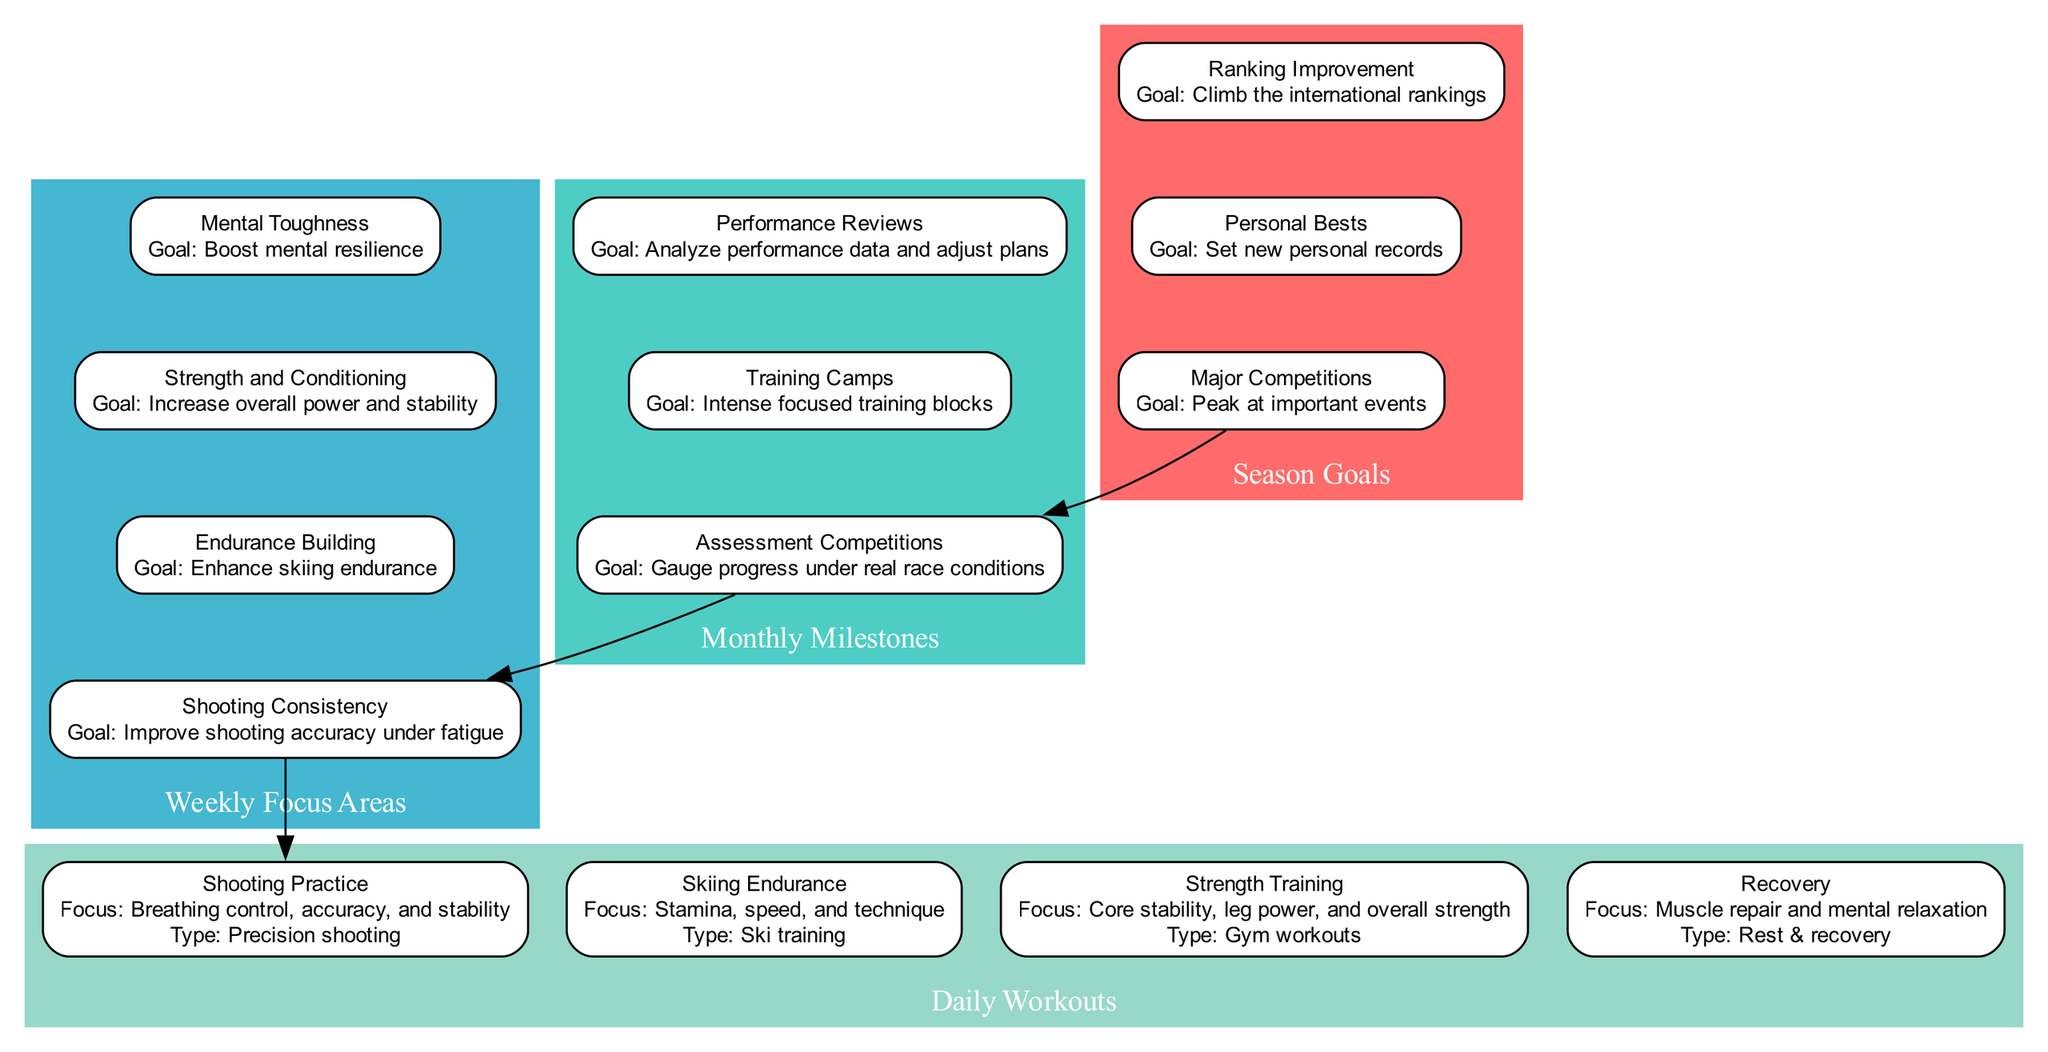What are the goals of the Major Competitions? The Major Competitions node lists the goal as "Peak at important events". This is the key information derived directly from that specific node in the diagram.
Answer: Peak at important events How many types of Daily Workouts are included? The Daily Workouts section contains four distinct types of workouts: Shooting Practice, Skiing Endurance, Strength Training, and Recovery. Counting them gives a total of four.
Answer: 4 What is the focus of Strength and Conditioning? According to the Strength and Conditioning node, the focus is stated as "Increase overall power and stability". This is directly taken from the details of that node.
Answer: Increase overall power and stability Which monthly milestone includes events? The Monthly Milestones node contains three items, but only Assessment Competitions and Training Camps explicitly list "events". Assessment Competitions lists "IBU Cup Competitions" and "Czech National Championships".
Answer: Assessment Competitions What methods are used to build shooting consistency? The Shooting Consistency node specifies two methods: "Simulated race conditions" and "Mixed shooting sessions". This combination indicates the training focus for achieving consistent shooting performance.
Answer: Simulated race conditions, Mixed shooting sessions What are the focus areas of the weekly training schedule? The Weekly Focus Areas section contains four distinct focus areas, which are: Shooting Consistency, Endurance Building, Strength and Conditioning, and Mental Toughness. These areas collectively represent the training priorities for the week.
Answer: Shooting Consistency, Endurance Building, Strength and Conditioning, Mental Toughness How does the Strength Training connect to the Daily Workouts? In the diagram, the Strength Training node in Daily Workouts is connected to Recovery, indicating that Recovery follows Strength Training as one of the workouts. This shows the relationship between daily workout routines.
Answer: Recovery What is the goal of the Performance Reviews? The Performance Reviews node defines the goal as "Analyze performance data and adjust plans". This is explicitly mentioned in the details of that node and signifies the purpose of conducting performance reviews.
Answer: Analyze performance data and adjust plans 